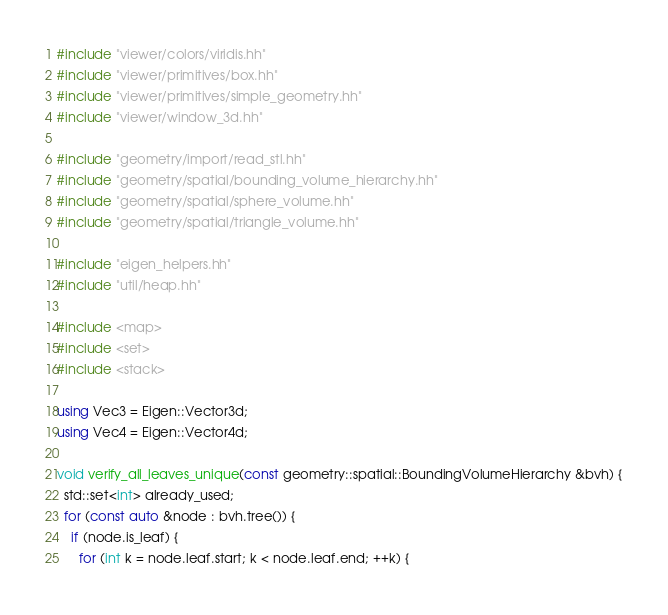Convert code to text. <code><loc_0><loc_0><loc_500><loc_500><_C++_>#include "viewer/colors/viridis.hh"
#include "viewer/primitives/box.hh"
#include "viewer/primitives/simple_geometry.hh"
#include "viewer/window_3d.hh"

#include "geometry/import/read_stl.hh"
#include "geometry/spatial/bounding_volume_hierarchy.hh"
#include "geometry/spatial/sphere_volume.hh"
#include "geometry/spatial/triangle_volume.hh"

#include "eigen_helpers.hh"
#include "util/heap.hh"

#include <map>
#include <set>
#include <stack>

using Vec3 = Eigen::Vector3d;
using Vec4 = Eigen::Vector4d;

void verify_all_leaves_unique(const geometry::spatial::BoundingVolumeHierarchy &bvh) {
  std::set<int> already_used;
  for (const auto &node : bvh.tree()) {
    if (node.is_leaf) {
      for (int k = node.leaf.start; k < node.leaf.end; ++k) {</code> 